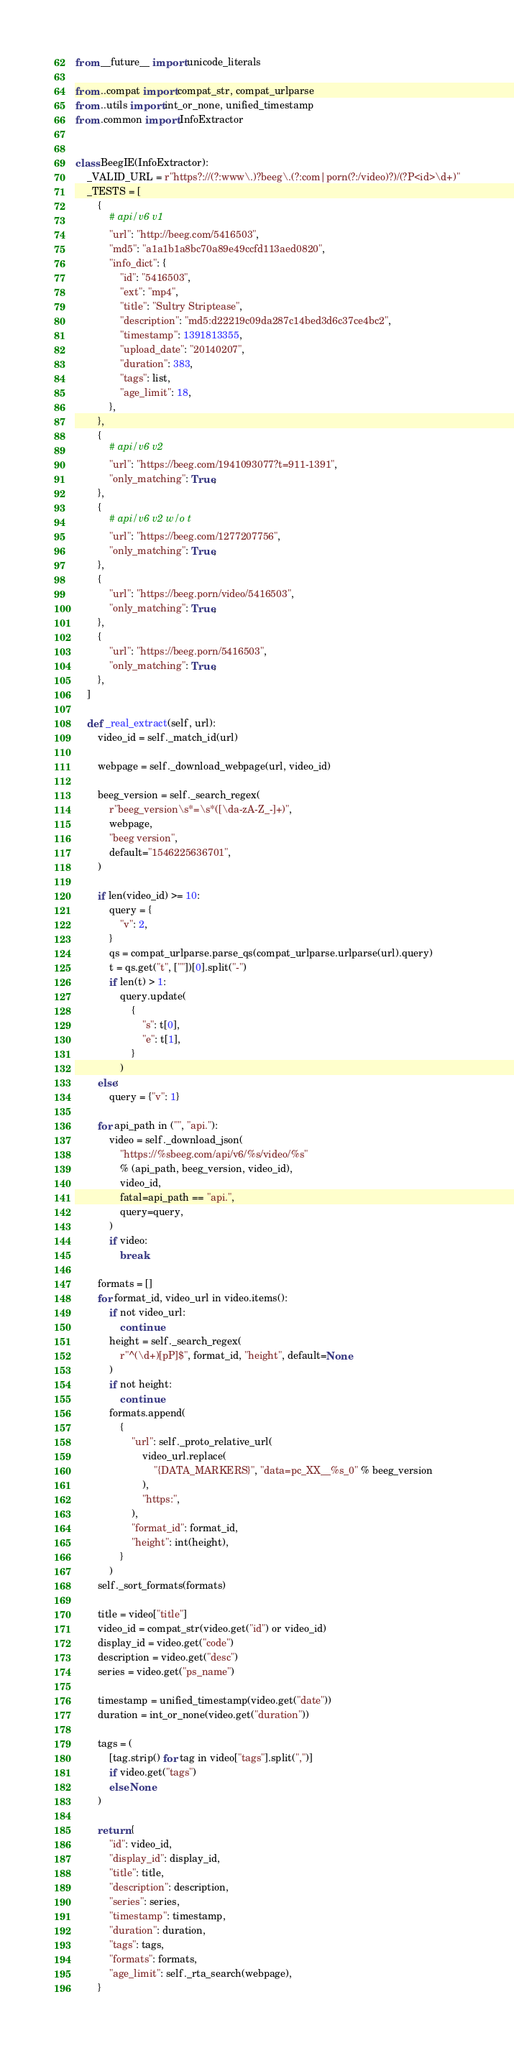<code> <loc_0><loc_0><loc_500><loc_500><_Python_>from __future__ import unicode_literals

from ..compat import compat_str, compat_urlparse
from ..utils import int_or_none, unified_timestamp
from .common import InfoExtractor


class BeegIE(InfoExtractor):
    _VALID_URL = r"https?://(?:www\.)?beeg\.(?:com|porn(?:/video)?)/(?P<id>\d+)"
    _TESTS = [
        {
            # api/v6 v1
            "url": "http://beeg.com/5416503",
            "md5": "a1a1b1a8bc70a89e49ccfd113aed0820",
            "info_dict": {
                "id": "5416503",
                "ext": "mp4",
                "title": "Sultry Striptease",
                "description": "md5:d22219c09da287c14bed3d6c37ce4bc2",
                "timestamp": 1391813355,
                "upload_date": "20140207",
                "duration": 383,
                "tags": list,
                "age_limit": 18,
            },
        },
        {
            # api/v6 v2
            "url": "https://beeg.com/1941093077?t=911-1391",
            "only_matching": True,
        },
        {
            # api/v6 v2 w/o t
            "url": "https://beeg.com/1277207756",
            "only_matching": True,
        },
        {
            "url": "https://beeg.porn/video/5416503",
            "only_matching": True,
        },
        {
            "url": "https://beeg.porn/5416503",
            "only_matching": True,
        },
    ]

    def _real_extract(self, url):
        video_id = self._match_id(url)

        webpage = self._download_webpage(url, video_id)

        beeg_version = self._search_regex(
            r"beeg_version\s*=\s*([\da-zA-Z_-]+)",
            webpage,
            "beeg version",
            default="1546225636701",
        )

        if len(video_id) >= 10:
            query = {
                "v": 2,
            }
            qs = compat_urlparse.parse_qs(compat_urlparse.urlparse(url).query)
            t = qs.get("t", [""])[0].split("-")
            if len(t) > 1:
                query.update(
                    {
                        "s": t[0],
                        "e": t[1],
                    }
                )
        else:
            query = {"v": 1}

        for api_path in ("", "api."):
            video = self._download_json(
                "https://%sbeeg.com/api/v6/%s/video/%s"
                % (api_path, beeg_version, video_id),
                video_id,
                fatal=api_path == "api.",
                query=query,
            )
            if video:
                break

        formats = []
        for format_id, video_url in video.items():
            if not video_url:
                continue
            height = self._search_regex(
                r"^(\d+)[pP]$", format_id, "height", default=None
            )
            if not height:
                continue
            formats.append(
                {
                    "url": self._proto_relative_url(
                        video_url.replace(
                            "{DATA_MARKERS}", "data=pc_XX__%s_0" % beeg_version
                        ),
                        "https:",
                    ),
                    "format_id": format_id,
                    "height": int(height),
                }
            )
        self._sort_formats(formats)

        title = video["title"]
        video_id = compat_str(video.get("id") or video_id)
        display_id = video.get("code")
        description = video.get("desc")
        series = video.get("ps_name")

        timestamp = unified_timestamp(video.get("date"))
        duration = int_or_none(video.get("duration"))

        tags = (
            [tag.strip() for tag in video["tags"].split(",")]
            if video.get("tags")
            else None
        )

        return {
            "id": video_id,
            "display_id": display_id,
            "title": title,
            "description": description,
            "series": series,
            "timestamp": timestamp,
            "duration": duration,
            "tags": tags,
            "formats": formats,
            "age_limit": self._rta_search(webpage),
        }
</code> 